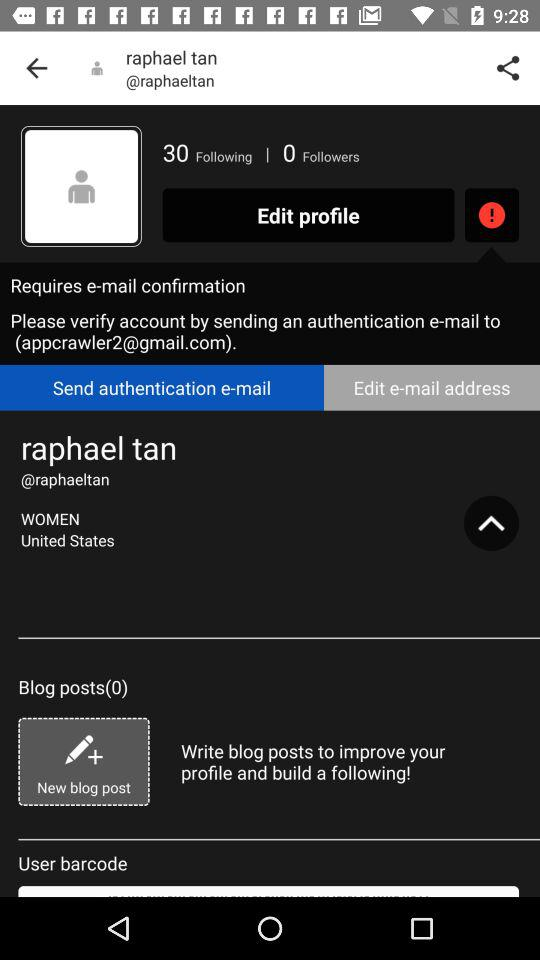How many blog posts does Raphael Tan have?
Answer the question using a single word or phrase. 0 